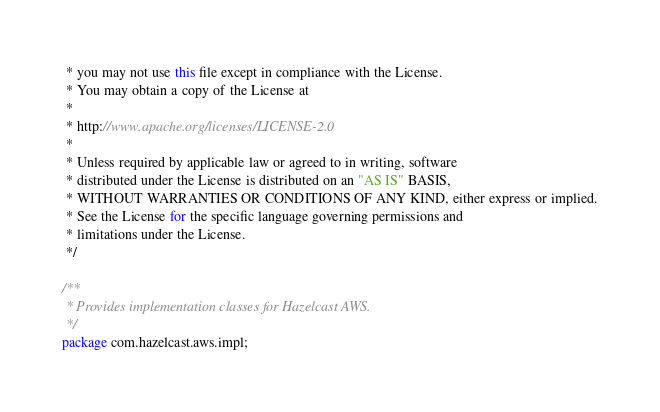<code> <loc_0><loc_0><loc_500><loc_500><_Java_> * you may not use this file except in compliance with the License.
 * You may obtain a copy of the License at
 *
 * http://www.apache.org/licenses/LICENSE-2.0
 *
 * Unless required by applicable law or agreed to in writing, software
 * distributed under the License is distributed on an "AS IS" BASIS,
 * WITHOUT WARRANTIES OR CONDITIONS OF ANY KIND, either express or implied.
 * See the License for the specific language governing permissions and
 * limitations under the License.
 */

/**
 * Provides implementation classes for Hazelcast AWS.
 */
package com.hazelcast.aws.impl;
</code> 